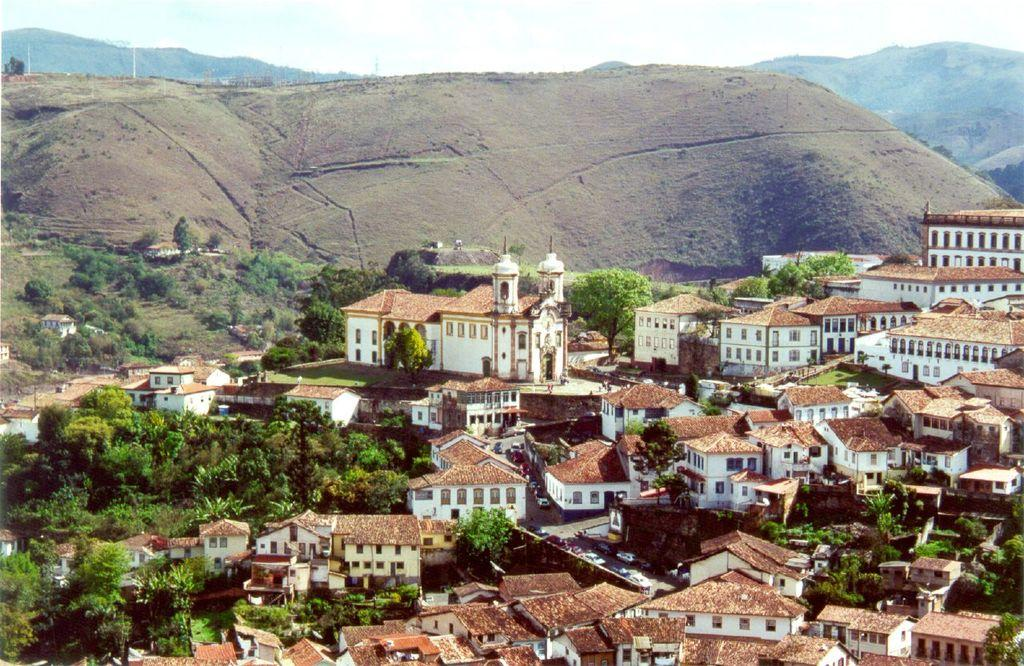What can be seen in the foreground of the image? There are trees, houses, and buildings in the foreground of the image. What is visible in the background of the image? There are mountains, poles, and the sky in the background of the image. What type of location is the image taken at? The image is taken near a hill station. What type of shock can be seen in the image? There is no shock present in the image. What hobbies are the trees in the image engaged in? Trees do not have hobbies, as they are inanimate objects. 